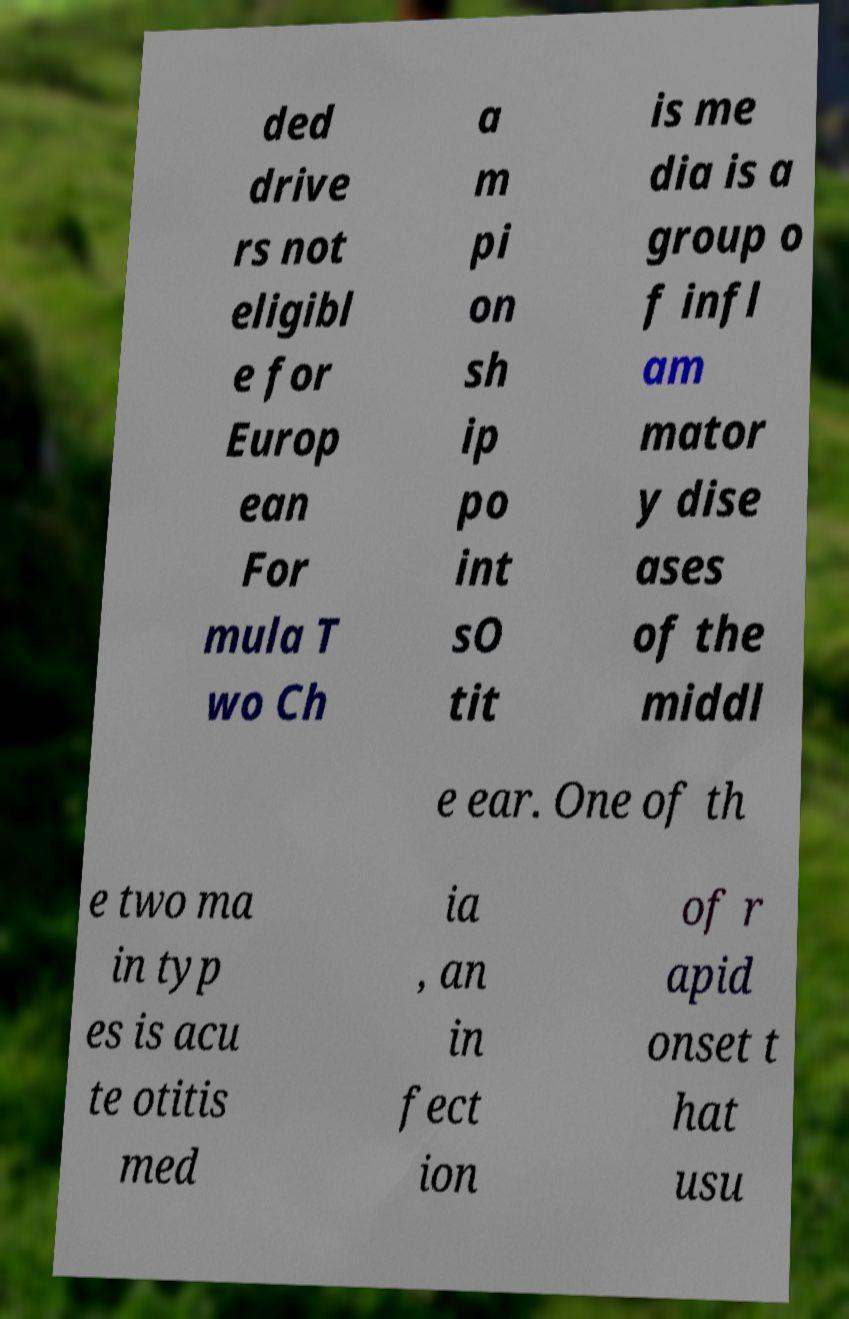Could you extract and type out the text from this image? ded drive rs not eligibl e for Europ ean For mula T wo Ch a m pi on sh ip po int sO tit is me dia is a group o f infl am mator y dise ases of the middl e ear. One of th e two ma in typ es is acu te otitis med ia , an in fect ion of r apid onset t hat usu 